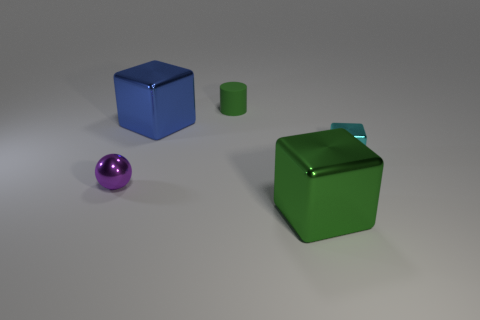Is there any other thing that is made of the same material as the cylinder?
Keep it short and to the point. No. The tiny cylinder behind the thing that is to the left of the big thing left of the matte object is what color?
Give a very brief answer. Green. Is the shape of the large metallic object in front of the tiny cyan metal thing the same as  the big blue metallic thing?
Make the answer very short. Yes. What number of small gray shiny things are there?
Ensure brevity in your answer.  0. How many cyan metal objects are the same size as the green rubber object?
Make the answer very short. 1. What is the material of the purple sphere?
Your response must be concise. Metal. There is a small metallic sphere; is its color the same as the big shiny block behind the small metal ball?
Offer a very short reply. No. There is a shiny object that is both on the left side of the big green object and to the right of the tiny purple metallic sphere; what size is it?
Provide a short and direct response. Large. What is the shape of the large green object that is the same material as the small purple object?
Provide a succinct answer. Cube. Is the material of the blue thing the same as the green object behind the purple object?
Offer a very short reply. No. 